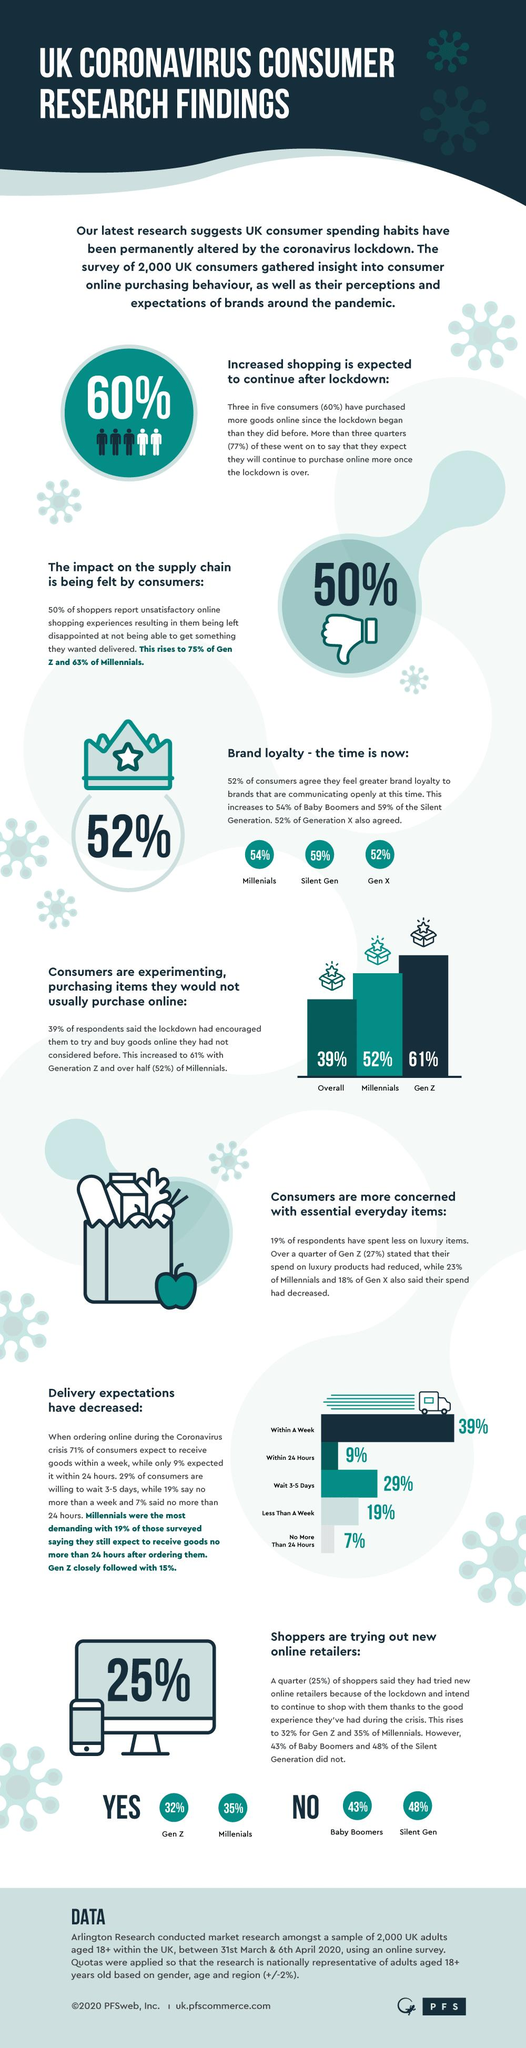Indicate a few pertinent items in this graphic. According to data, Generation Z has a lower percentage of reduced spending on luxury items compared to Generation X. Specifically, the percentage of reduced spending on luxury items by Generation Z is 9%. Research has shown that baby boomers and members of the silent generation are less likely to try out new online retailers compared to other generations. Millennials are less likely to try new things while shopping online than generation Z. Shoppers from different generations, including Generation Z and millennials, are trying out new online retailers. Millennials are the least demanding generation after Gen Z. 